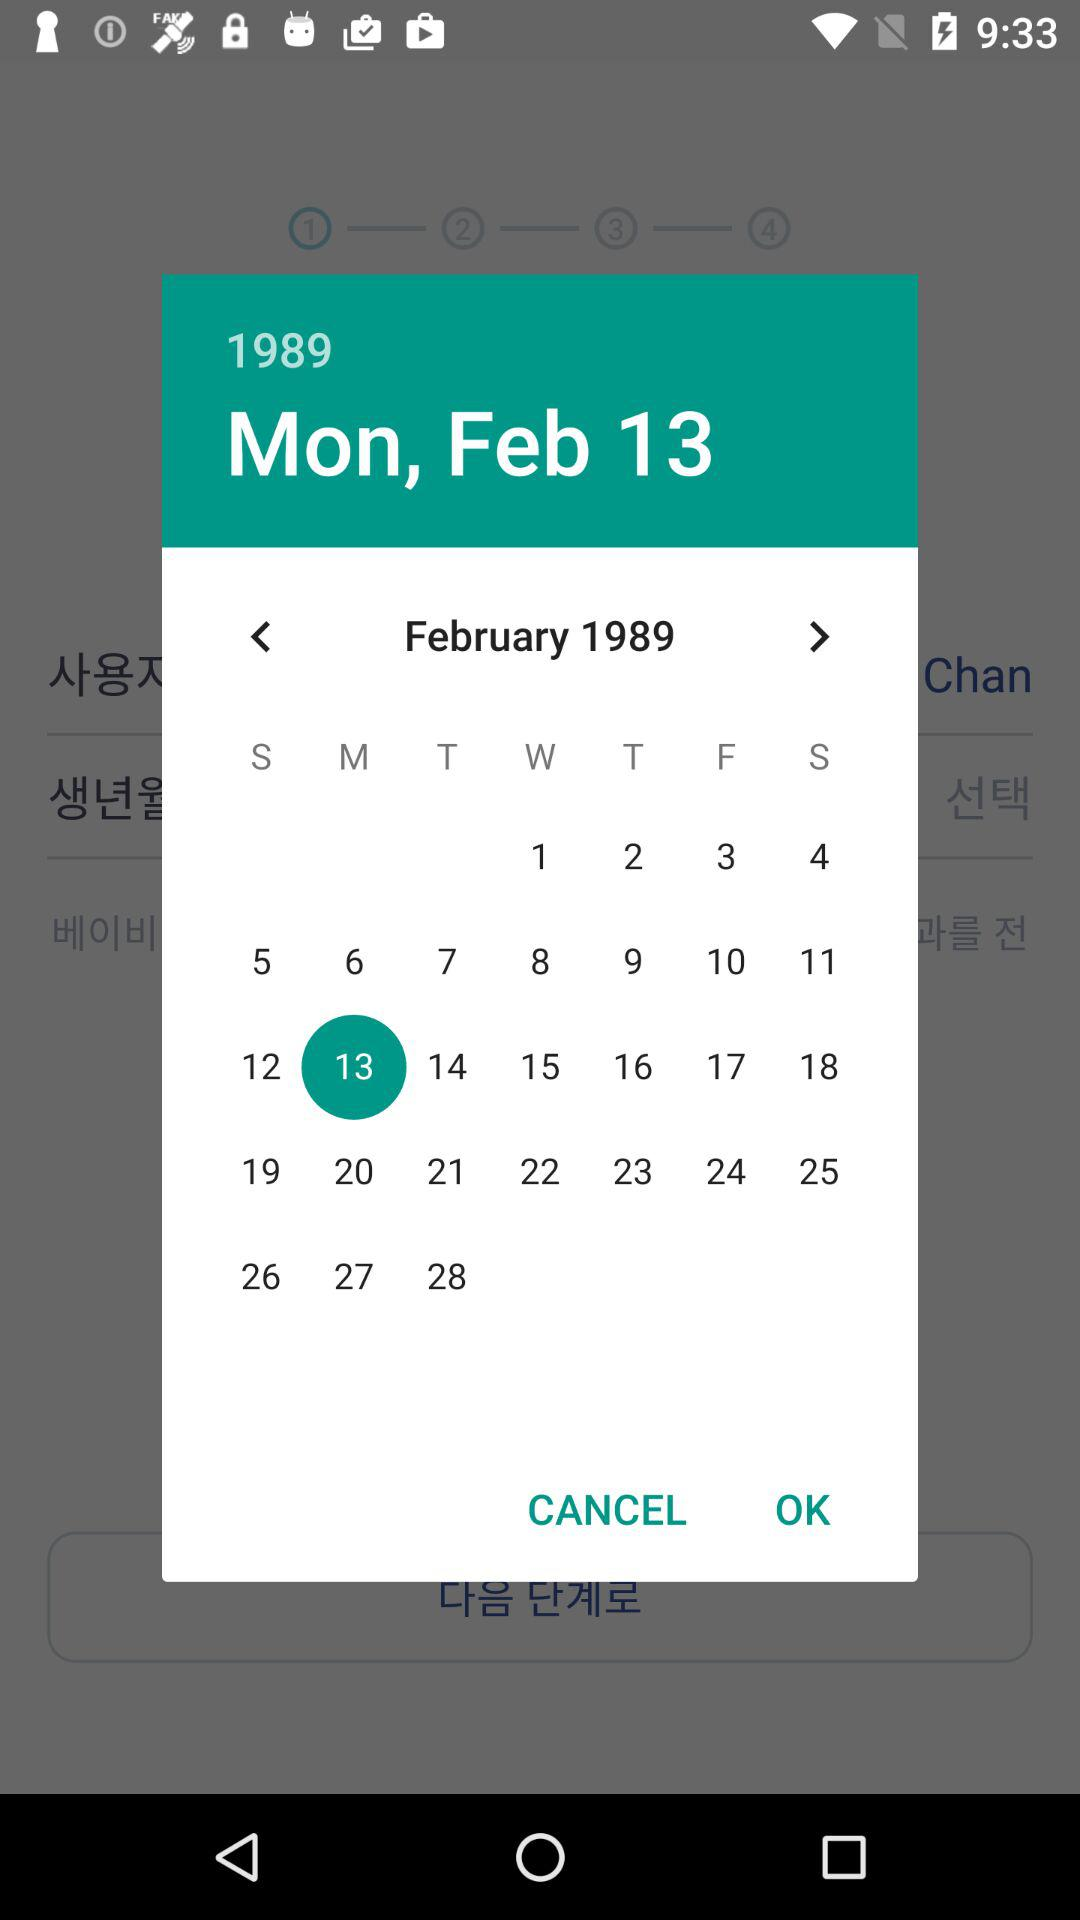What is the mentioned date? The mentioned date is Monday, February 13, 1989. 